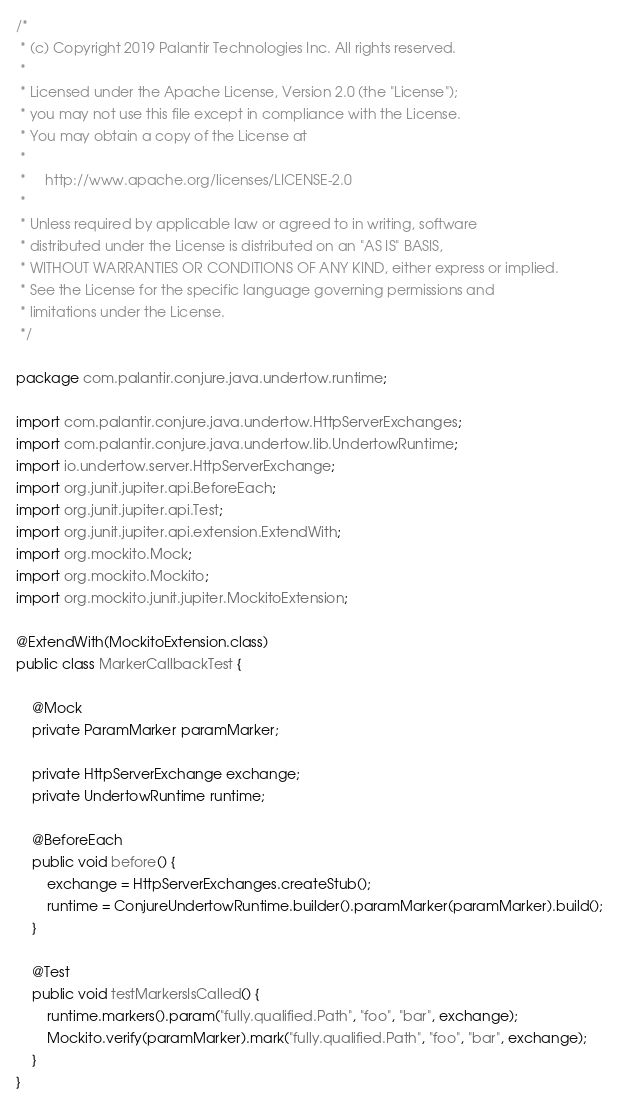Convert code to text. <code><loc_0><loc_0><loc_500><loc_500><_Java_>/*
 * (c) Copyright 2019 Palantir Technologies Inc. All rights reserved.
 *
 * Licensed under the Apache License, Version 2.0 (the "License");
 * you may not use this file except in compliance with the License.
 * You may obtain a copy of the License at
 *
 *     http://www.apache.org/licenses/LICENSE-2.0
 *
 * Unless required by applicable law or agreed to in writing, software
 * distributed under the License is distributed on an "AS IS" BASIS,
 * WITHOUT WARRANTIES OR CONDITIONS OF ANY KIND, either express or implied.
 * See the License for the specific language governing permissions and
 * limitations under the License.
 */

package com.palantir.conjure.java.undertow.runtime;

import com.palantir.conjure.java.undertow.HttpServerExchanges;
import com.palantir.conjure.java.undertow.lib.UndertowRuntime;
import io.undertow.server.HttpServerExchange;
import org.junit.jupiter.api.BeforeEach;
import org.junit.jupiter.api.Test;
import org.junit.jupiter.api.extension.ExtendWith;
import org.mockito.Mock;
import org.mockito.Mockito;
import org.mockito.junit.jupiter.MockitoExtension;

@ExtendWith(MockitoExtension.class)
public class MarkerCallbackTest {

    @Mock
    private ParamMarker paramMarker;

    private HttpServerExchange exchange;
    private UndertowRuntime runtime;

    @BeforeEach
    public void before() {
        exchange = HttpServerExchanges.createStub();
        runtime = ConjureUndertowRuntime.builder().paramMarker(paramMarker).build();
    }

    @Test
    public void testMarkersIsCalled() {
        runtime.markers().param("fully.qualified.Path", "foo", "bar", exchange);
        Mockito.verify(paramMarker).mark("fully.qualified.Path", "foo", "bar", exchange);
    }
}
</code> 